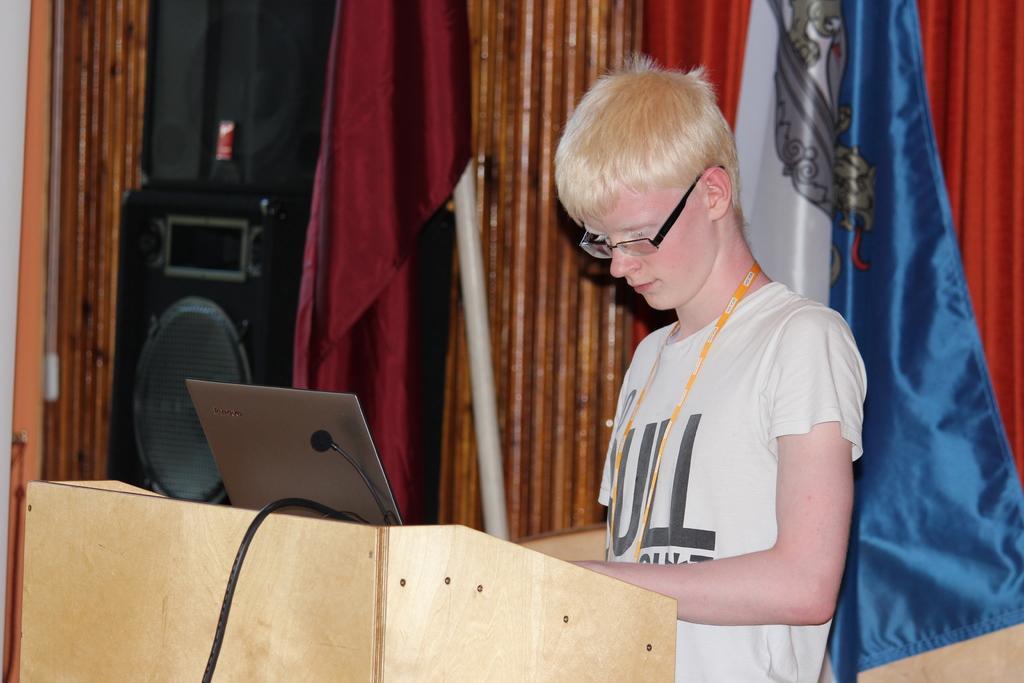In one or two sentences, can you explain what this image depicts? In this image we can see a man standing beside a speaker stand containing a laptop, wire and a mic on it. On the backside we can see the flags, a speaker box, a pole and some curtains. 